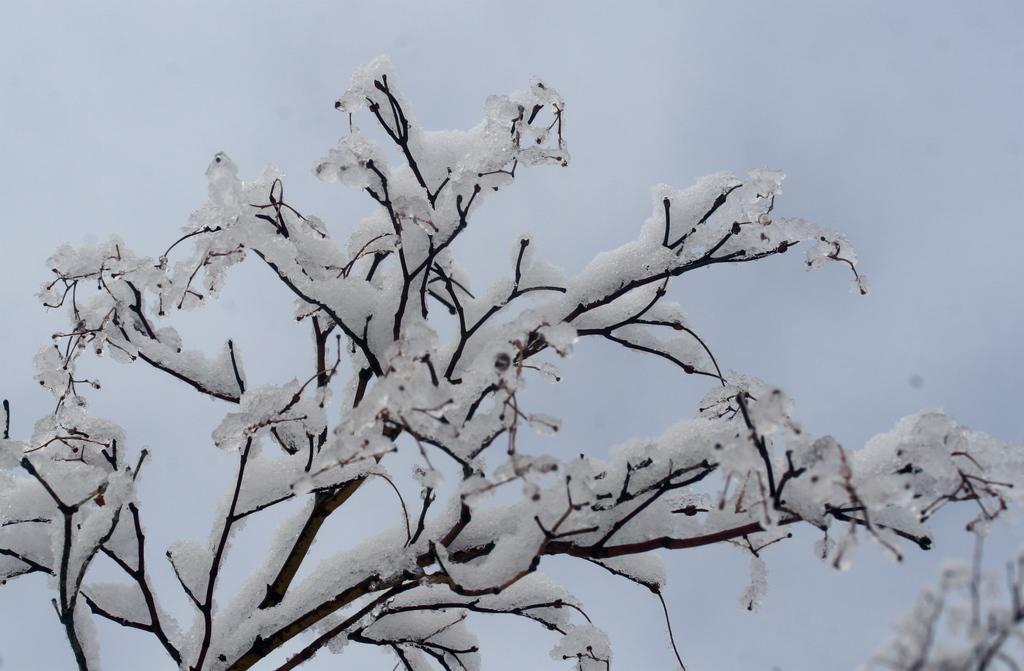In one or two sentences, can you explain what this image depicts? In this image, I can see a tree, which is covered with the snow. In the background, there is the sky. 